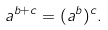<formula> <loc_0><loc_0><loc_500><loc_500>a ^ { b + c } = ( a ^ { b } ) ^ { c } .</formula> 